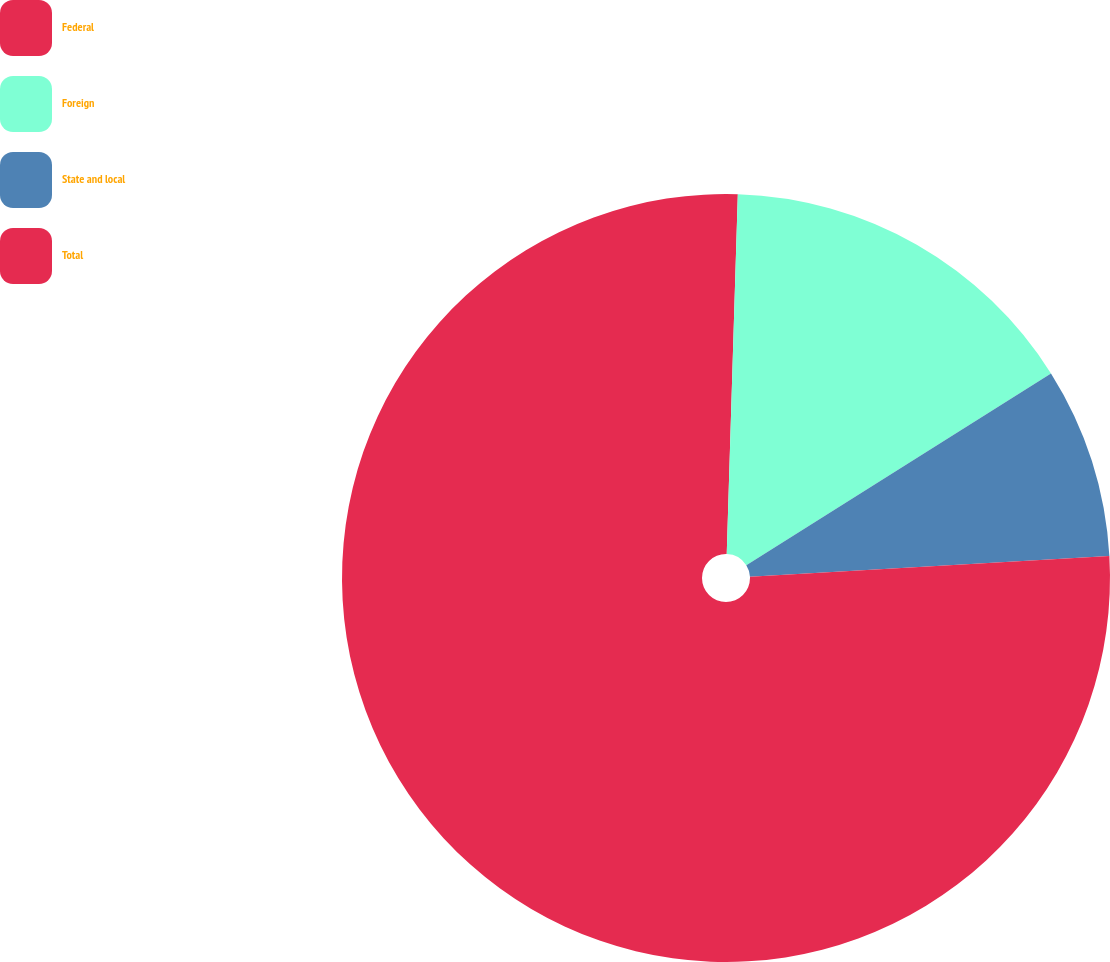Convert chart to OTSL. <chart><loc_0><loc_0><loc_500><loc_500><pie_chart><fcel>Federal<fcel>Foreign<fcel>State and local<fcel>Total<nl><fcel>0.49%<fcel>15.57%<fcel>8.03%<fcel>75.91%<nl></chart> 